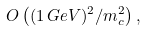<formula> <loc_0><loc_0><loc_500><loc_500>O \left ( ( 1 \, G e V ) ^ { 2 } / m _ { c } ^ { 2 } \right ) ,</formula> 